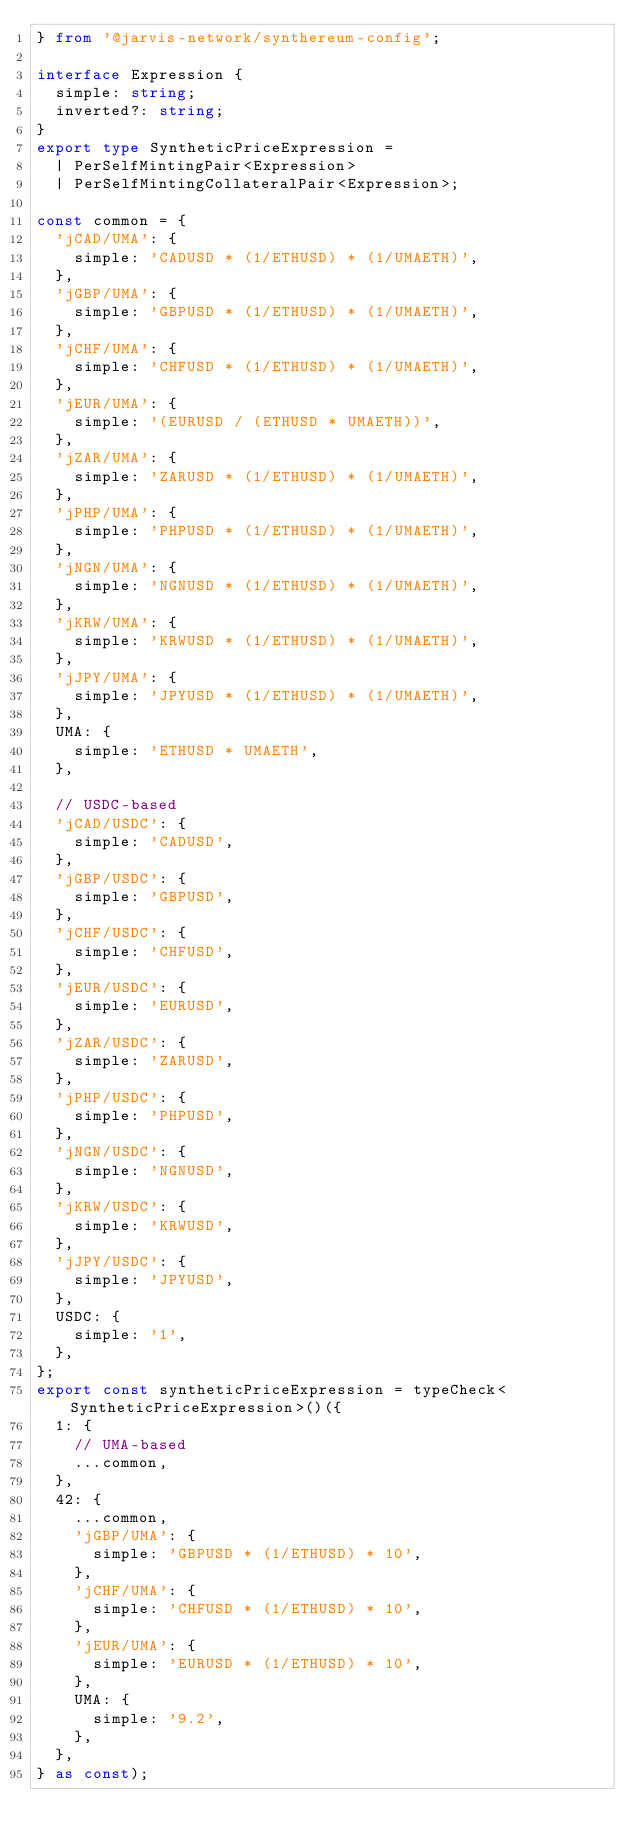Convert code to text. <code><loc_0><loc_0><loc_500><loc_500><_TypeScript_>} from '@jarvis-network/synthereum-config';

interface Expression {
  simple: string;
  inverted?: string;
}
export type SyntheticPriceExpression =
  | PerSelfMintingPair<Expression>
  | PerSelfMintingCollateralPair<Expression>;

const common = {
  'jCAD/UMA': {
    simple: 'CADUSD * (1/ETHUSD) * (1/UMAETH)',
  },
  'jGBP/UMA': {
    simple: 'GBPUSD * (1/ETHUSD) * (1/UMAETH)',
  },
  'jCHF/UMA': {
    simple: 'CHFUSD * (1/ETHUSD) * (1/UMAETH)',
  },
  'jEUR/UMA': {
    simple: '(EURUSD / (ETHUSD * UMAETH))',
  },
  'jZAR/UMA': {
    simple: 'ZARUSD * (1/ETHUSD) * (1/UMAETH)',
  },
  'jPHP/UMA': {
    simple: 'PHPUSD * (1/ETHUSD) * (1/UMAETH)',
  },
  'jNGN/UMA': {
    simple: 'NGNUSD * (1/ETHUSD) * (1/UMAETH)',
  },
  'jKRW/UMA': {
    simple: 'KRWUSD * (1/ETHUSD) * (1/UMAETH)',
  },
  'jJPY/UMA': {
    simple: 'JPYUSD * (1/ETHUSD) * (1/UMAETH)',
  },
  UMA: {
    simple: 'ETHUSD * UMAETH',
  },

  // USDC-based
  'jCAD/USDC': {
    simple: 'CADUSD',
  },
  'jGBP/USDC': {
    simple: 'GBPUSD',
  },
  'jCHF/USDC': {
    simple: 'CHFUSD',
  },
  'jEUR/USDC': {
    simple: 'EURUSD',
  },
  'jZAR/USDC': {
    simple: 'ZARUSD',
  },
  'jPHP/USDC': {
    simple: 'PHPUSD',
  },
  'jNGN/USDC': {
    simple: 'NGNUSD',
  },
  'jKRW/USDC': {
    simple: 'KRWUSD',
  },
  'jJPY/USDC': {
    simple: 'JPYUSD',
  },
  USDC: {
    simple: '1',
  },
};
export const syntheticPriceExpression = typeCheck<SyntheticPriceExpression>()({
  1: {
    // UMA-based
    ...common,
  },
  42: {
    ...common,
    'jGBP/UMA': {
      simple: 'GBPUSD * (1/ETHUSD) * 10',
    },
    'jCHF/UMA': {
      simple: 'CHFUSD * (1/ETHUSD) * 10',
    },
    'jEUR/UMA': {
      simple: 'EURUSD * (1/ETHUSD) * 10',
    },
    UMA: {
      simple: '9.2',
    },
  },
} as const);
</code> 